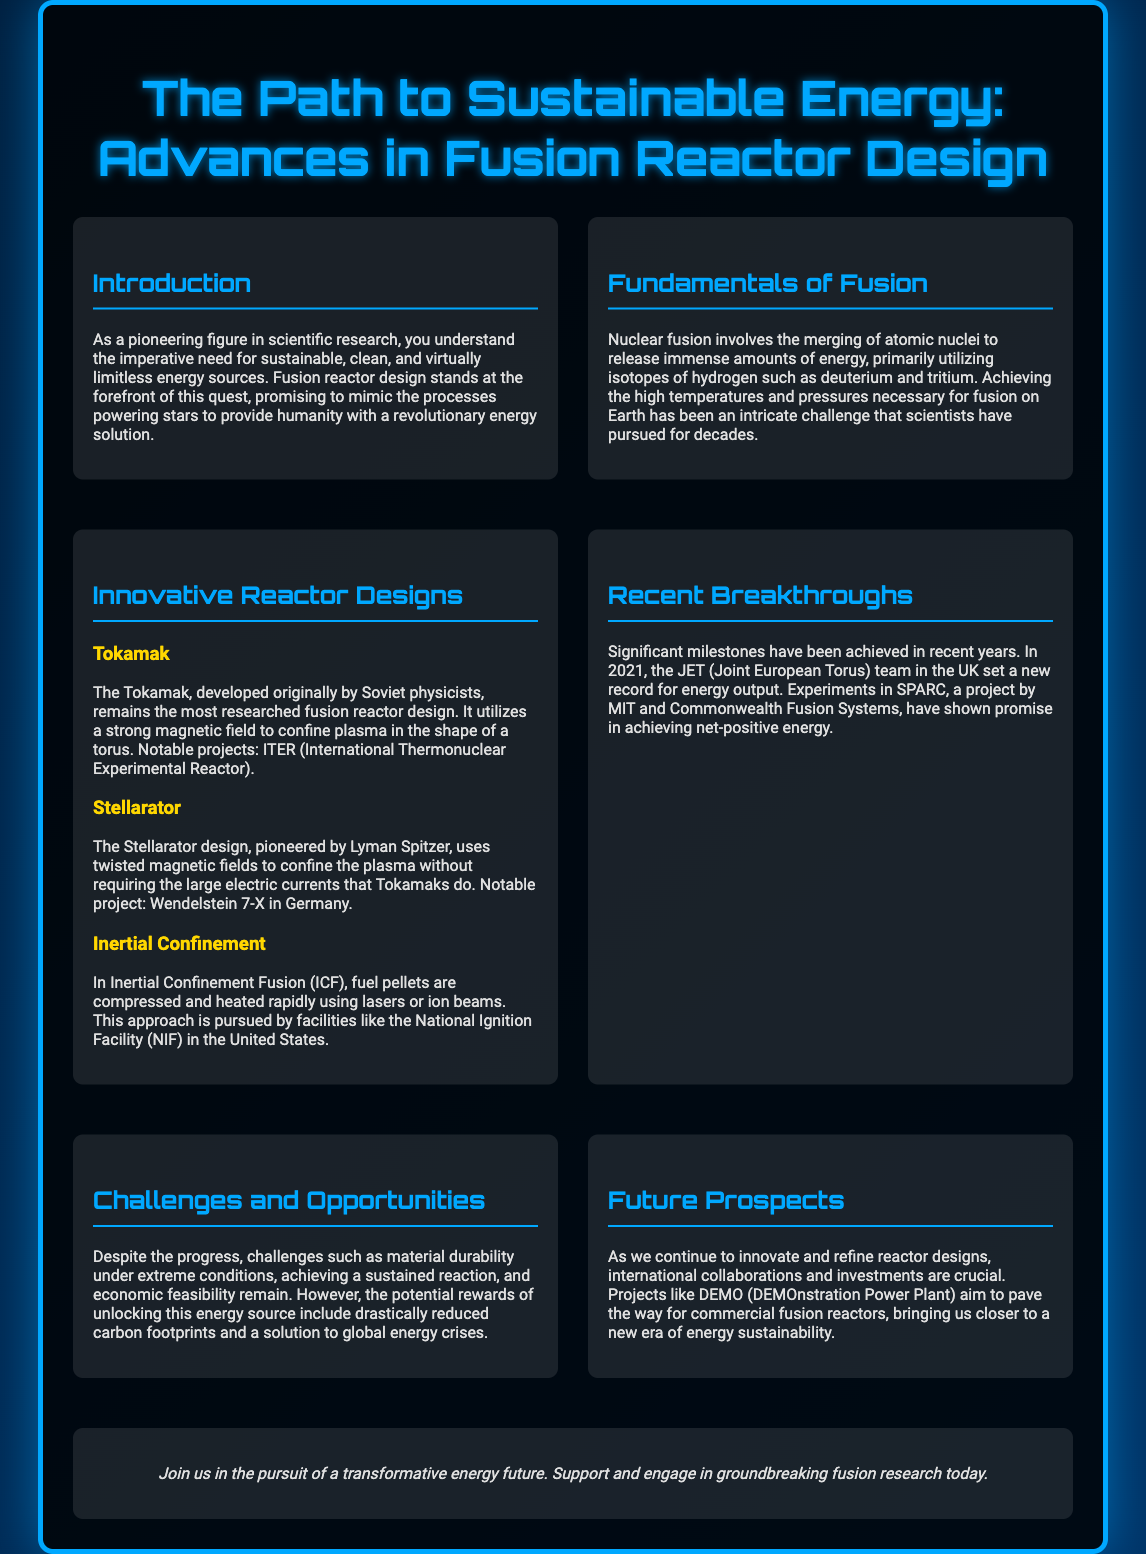what is the primary focus of the poster? The poster discusses sustainable energy through advances in fusion reactor design.
Answer: sustainable energy who developed the Tokamak design? The Tokamak was developed originally by Soviet physicists.
Answer: Soviet physicists what is a notable project related to the Stellarator? The notable project related to the Stellarator is Wendelstein 7-X.
Answer: Wendelstein 7-X when did the JET team set a new record for energy output? The JET team set a new record for energy output in 2021.
Answer: 2021 what is the challenge mentioned regarding fusion reactor designs? The document mentions material durability under extreme conditions as a challenge.
Answer: material durability what is the purpose of the DEMO project? The DEMO project aims to pave the way for commercial fusion reactors.
Answer: pave the way for commercial fusion reactors what is one of the isotopes used in nuclear fusion? Deuterium is one of the isotopes used in nuclear fusion.
Answer: Deuterium which facility is involved with Inertial Confinement Fusion? The National Ignition Facility (NIF) is involved with Inertial Confinement Fusion.
Answer: National Ignition Facility (NIF) 